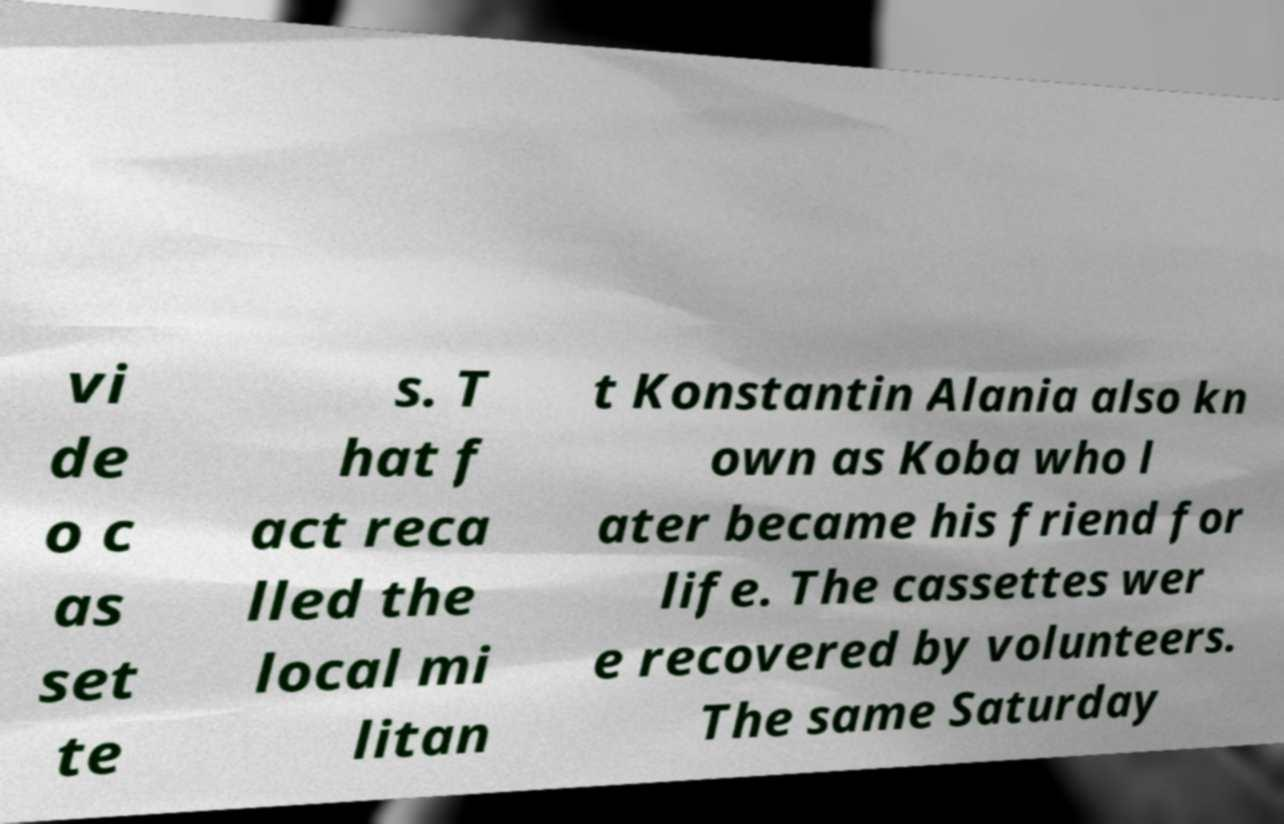There's text embedded in this image that I need extracted. Can you transcribe it verbatim? vi de o c as set te s. T hat f act reca lled the local mi litan t Konstantin Alania also kn own as Koba who l ater became his friend for life. The cassettes wer e recovered by volunteers. The same Saturday 